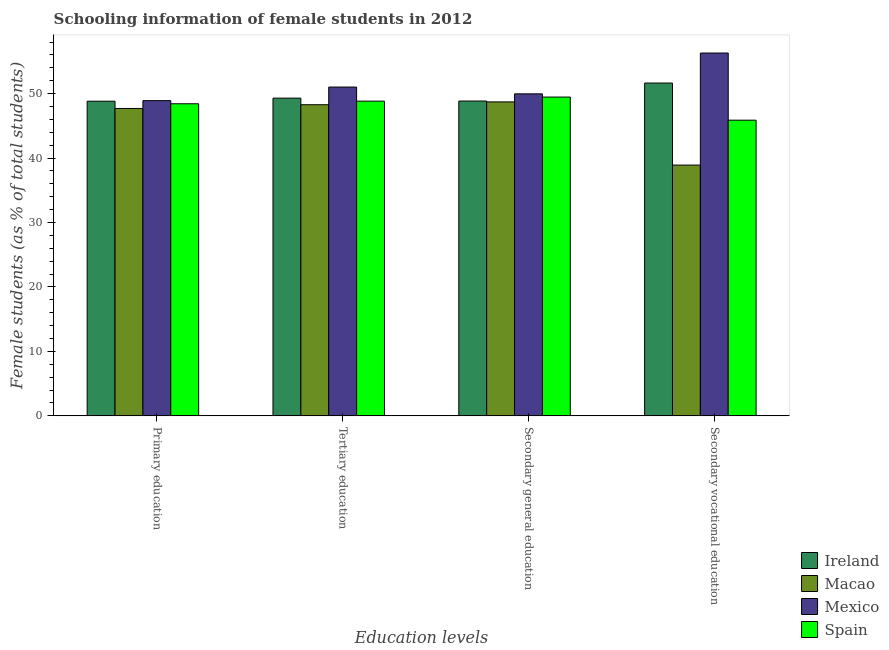How many different coloured bars are there?
Provide a succinct answer. 4. How many groups of bars are there?
Offer a very short reply. 4. Are the number of bars on each tick of the X-axis equal?
Offer a very short reply. Yes. How many bars are there on the 1st tick from the left?
Your response must be concise. 4. How many bars are there on the 2nd tick from the right?
Provide a short and direct response. 4. What is the label of the 3rd group of bars from the left?
Make the answer very short. Secondary general education. What is the percentage of female students in primary education in Macao?
Provide a short and direct response. 47.7. Across all countries, what is the maximum percentage of female students in tertiary education?
Offer a terse response. 51.02. Across all countries, what is the minimum percentage of female students in secondary vocational education?
Give a very brief answer. 38.91. In which country was the percentage of female students in secondary vocational education minimum?
Your response must be concise. Macao. What is the total percentage of female students in secondary education in the graph?
Your answer should be compact. 197. What is the difference between the percentage of female students in primary education in Ireland and that in Spain?
Make the answer very short. 0.4. What is the difference between the percentage of female students in primary education in Spain and the percentage of female students in secondary vocational education in Macao?
Offer a terse response. 9.51. What is the average percentage of female students in tertiary education per country?
Ensure brevity in your answer.  49.36. What is the difference between the percentage of female students in secondary education and percentage of female students in primary education in Ireland?
Your answer should be compact. 0.02. In how many countries, is the percentage of female students in secondary vocational education greater than 8 %?
Provide a short and direct response. 4. What is the ratio of the percentage of female students in primary education in Mexico to that in Spain?
Your answer should be compact. 1.01. What is the difference between the highest and the second highest percentage of female students in secondary vocational education?
Keep it short and to the point. 4.66. What is the difference between the highest and the lowest percentage of female students in secondary education?
Make the answer very short. 1.25. In how many countries, is the percentage of female students in tertiary education greater than the average percentage of female students in tertiary education taken over all countries?
Your answer should be compact. 1. Is the sum of the percentage of female students in primary education in Spain and Ireland greater than the maximum percentage of female students in secondary vocational education across all countries?
Your response must be concise. Yes. Is it the case that in every country, the sum of the percentage of female students in secondary vocational education and percentage of female students in tertiary education is greater than the sum of percentage of female students in primary education and percentage of female students in secondary education?
Make the answer very short. Yes. What does the 1st bar from the left in Primary education represents?
Your answer should be very brief. Ireland. What does the 2nd bar from the right in Primary education represents?
Keep it short and to the point. Mexico. Is it the case that in every country, the sum of the percentage of female students in primary education and percentage of female students in tertiary education is greater than the percentage of female students in secondary education?
Offer a terse response. Yes. How many countries are there in the graph?
Your response must be concise. 4. What is the difference between two consecutive major ticks on the Y-axis?
Make the answer very short. 10. Are the values on the major ticks of Y-axis written in scientific E-notation?
Your answer should be very brief. No. Does the graph contain grids?
Your response must be concise. No. Where does the legend appear in the graph?
Offer a very short reply. Bottom right. How many legend labels are there?
Make the answer very short. 4. What is the title of the graph?
Provide a succinct answer. Schooling information of female students in 2012. Does "Tunisia" appear as one of the legend labels in the graph?
Give a very brief answer. No. What is the label or title of the X-axis?
Offer a terse response. Education levels. What is the label or title of the Y-axis?
Make the answer very short. Female students (as % of total students). What is the Female students (as % of total students) of Ireland in Primary education?
Ensure brevity in your answer.  48.83. What is the Female students (as % of total students) in Macao in Primary education?
Offer a terse response. 47.7. What is the Female students (as % of total students) of Mexico in Primary education?
Give a very brief answer. 48.91. What is the Female students (as % of total students) in Spain in Primary education?
Offer a very short reply. 48.43. What is the Female students (as % of total students) in Ireland in Tertiary education?
Offer a terse response. 49.3. What is the Female students (as % of total students) of Macao in Tertiary education?
Your answer should be compact. 48.28. What is the Female students (as % of total students) of Mexico in Tertiary education?
Give a very brief answer. 51.02. What is the Female students (as % of total students) of Spain in Tertiary education?
Provide a short and direct response. 48.83. What is the Female students (as % of total students) of Ireland in Secondary general education?
Give a very brief answer. 48.85. What is the Female students (as % of total students) of Macao in Secondary general education?
Your answer should be very brief. 48.72. What is the Female students (as % of total students) in Mexico in Secondary general education?
Keep it short and to the point. 49.97. What is the Female students (as % of total students) in Spain in Secondary general education?
Make the answer very short. 49.47. What is the Female students (as % of total students) of Ireland in Secondary vocational education?
Provide a short and direct response. 51.64. What is the Female students (as % of total students) of Macao in Secondary vocational education?
Offer a very short reply. 38.91. What is the Female students (as % of total students) in Mexico in Secondary vocational education?
Keep it short and to the point. 56.3. What is the Female students (as % of total students) of Spain in Secondary vocational education?
Offer a very short reply. 45.88. Across all Education levels, what is the maximum Female students (as % of total students) of Ireland?
Keep it short and to the point. 51.64. Across all Education levels, what is the maximum Female students (as % of total students) in Macao?
Keep it short and to the point. 48.72. Across all Education levels, what is the maximum Female students (as % of total students) in Mexico?
Your answer should be very brief. 56.3. Across all Education levels, what is the maximum Female students (as % of total students) of Spain?
Ensure brevity in your answer.  49.47. Across all Education levels, what is the minimum Female students (as % of total students) of Ireland?
Provide a short and direct response. 48.83. Across all Education levels, what is the minimum Female students (as % of total students) of Macao?
Make the answer very short. 38.91. Across all Education levels, what is the minimum Female students (as % of total students) of Mexico?
Keep it short and to the point. 48.91. Across all Education levels, what is the minimum Female students (as % of total students) in Spain?
Keep it short and to the point. 45.88. What is the total Female students (as % of total students) of Ireland in the graph?
Your answer should be compact. 198.62. What is the total Female students (as % of total students) in Macao in the graph?
Offer a very short reply. 183.61. What is the total Female students (as % of total students) of Mexico in the graph?
Your answer should be compact. 206.2. What is the total Female students (as % of total students) of Spain in the graph?
Your answer should be compact. 192.61. What is the difference between the Female students (as % of total students) in Ireland in Primary education and that in Tertiary education?
Provide a succinct answer. -0.48. What is the difference between the Female students (as % of total students) in Macao in Primary education and that in Tertiary education?
Your answer should be compact. -0.58. What is the difference between the Female students (as % of total students) in Mexico in Primary education and that in Tertiary education?
Provide a succinct answer. -2.11. What is the difference between the Female students (as % of total students) of Spain in Primary education and that in Tertiary education?
Your answer should be compact. -0.41. What is the difference between the Female students (as % of total students) of Ireland in Primary education and that in Secondary general education?
Provide a succinct answer. -0.02. What is the difference between the Female students (as % of total students) of Macao in Primary education and that in Secondary general education?
Offer a very short reply. -1.02. What is the difference between the Female students (as % of total students) of Mexico in Primary education and that in Secondary general education?
Make the answer very short. -1.05. What is the difference between the Female students (as % of total students) of Spain in Primary education and that in Secondary general education?
Provide a short and direct response. -1.04. What is the difference between the Female students (as % of total students) of Ireland in Primary education and that in Secondary vocational education?
Your answer should be compact. -2.82. What is the difference between the Female students (as % of total students) in Macao in Primary education and that in Secondary vocational education?
Give a very brief answer. 8.79. What is the difference between the Female students (as % of total students) in Mexico in Primary education and that in Secondary vocational education?
Your answer should be compact. -7.39. What is the difference between the Female students (as % of total students) in Spain in Primary education and that in Secondary vocational education?
Provide a short and direct response. 2.55. What is the difference between the Female students (as % of total students) in Ireland in Tertiary education and that in Secondary general education?
Your answer should be compact. 0.45. What is the difference between the Female students (as % of total students) of Macao in Tertiary education and that in Secondary general education?
Offer a terse response. -0.44. What is the difference between the Female students (as % of total students) in Mexico in Tertiary education and that in Secondary general education?
Give a very brief answer. 1.05. What is the difference between the Female students (as % of total students) of Spain in Tertiary education and that in Secondary general education?
Your answer should be very brief. -0.63. What is the difference between the Female students (as % of total students) of Ireland in Tertiary education and that in Secondary vocational education?
Your response must be concise. -2.34. What is the difference between the Female students (as % of total students) of Macao in Tertiary education and that in Secondary vocational education?
Your answer should be very brief. 9.37. What is the difference between the Female students (as % of total students) of Mexico in Tertiary education and that in Secondary vocational education?
Offer a terse response. -5.28. What is the difference between the Female students (as % of total students) of Spain in Tertiary education and that in Secondary vocational education?
Keep it short and to the point. 2.95. What is the difference between the Female students (as % of total students) in Ireland in Secondary general education and that in Secondary vocational education?
Keep it short and to the point. -2.79. What is the difference between the Female students (as % of total students) of Macao in Secondary general education and that in Secondary vocational education?
Offer a very short reply. 9.8. What is the difference between the Female students (as % of total students) in Mexico in Secondary general education and that in Secondary vocational education?
Offer a terse response. -6.33. What is the difference between the Female students (as % of total students) in Spain in Secondary general education and that in Secondary vocational education?
Offer a very short reply. 3.59. What is the difference between the Female students (as % of total students) of Ireland in Primary education and the Female students (as % of total students) of Macao in Tertiary education?
Keep it short and to the point. 0.55. What is the difference between the Female students (as % of total students) in Ireland in Primary education and the Female students (as % of total students) in Mexico in Tertiary education?
Your answer should be very brief. -2.19. What is the difference between the Female students (as % of total students) in Ireland in Primary education and the Female students (as % of total students) in Spain in Tertiary education?
Give a very brief answer. -0.01. What is the difference between the Female students (as % of total students) in Macao in Primary education and the Female students (as % of total students) in Mexico in Tertiary education?
Offer a very short reply. -3.32. What is the difference between the Female students (as % of total students) in Macao in Primary education and the Female students (as % of total students) in Spain in Tertiary education?
Provide a succinct answer. -1.13. What is the difference between the Female students (as % of total students) of Mexico in Primary education and the Female students (as % of total students) of Spain in Tertiary education?
Provide a short and direct response. 0.08. What is the difference between the Female students (as % of total students) of Ireland in Primary education and the Female students (as % of total students) of Macao in Secondary general education?
Make the answer very short. 0.11. What is the difference between the Female students (as % of total students) of Ireland in Primary education and the Female students (as % of total students) of Mexico in Secondary general education?
Your answer should be compact. -1.14. What is the difference between the Female students (as % of total students) of Ireland in Primary education and the Female students (as % of total students) of Spain in Secondary general education?
Provide a short and direct response. -0.64. What is the difference between the Female students (as % of total students) in Macao in Primary education and the Female students (as % of total students) in Mexico in Secondary general education?
Make the answer very short. -2.27. What is the difference between the Female students (as % of total students) in Macao in Primary education and the Female students (as % of total students) in Spain in Secondary general education?
Offer a very short reply. -1.77. What is the difference between the Female students (as % of total students) in Mexico in Primary education and the Female students (as % of total students) in Spain in Secondary general education?
Make the answer very short. -0.55. What is the difference between the Female students (as % of total students) of Ireland in Primary education and the Female students (as % of total students) of Macao in Secondary vocational education?
Your answer should be compact. 9.91. What is the difference between the Female students (as % of total students) in Ireland in Primary education and the Female students (as % of total students) in Mexico in Secondary vocational education?
Offer a terse response. -7.48. What is the difference between the Female students (as % of total students) in Ireland in Primary education and the Female students (as % of total students) in Spain in Secondary vocational education?
Offer a terse response. 2.95. What is the difference between the Female students (as % of total students) in Macao in Primary education and the Female students (as % of total students) in Mexico in Secondary vocational education?
Offer a terse response. -8.6. What is the difference between the Female students (as % of total students) in Macao in Primary education and the Female students (as % of total students) in Spain in Secondary vocational education?
Make the answer very short. 1.82. What is the difference between the Female students (as % of total students) in Mexico in Primary education and the Female students (as % of total students) in Spain in Secondary vocational education?
Ensure brevity in your answer.  3.03. What is the difference between the Female students (as % of total students) of Ireland in Tertiary education and the Female students (as % of total students) of Macao in Secondary general education?
Offer a terse response. 0.58. What is the difference between the Female students (as % of total students) of Ireland in Tertiary education and the Female students (as % of total students) of Mexico in Secondary general education?
Keep it short and to the point. -0.67. What is the difference between the Female students (as % of total students) of Ireland in Tertiary education and the Female students (as % of total students) of Spain in Secondary general education?
Offer a terse response. -0.17. What is the difference between the Female students (as % of total students) of Macao in Tertiary education and the Female students (as % of total students) of Mexico in Secondary general education?
Offer a terse response. -1.69. What is the difference between the Female students (as % of total students) of Macao in Tertiary education and the Female students (as % of total students) of Spain in Secondary general education?
Provide a short and direct response. -1.19. What is the difference between the Female students (as % of total students) of Mexico in Tertiary education and the Female students (as % of total students) of Spain in Secondary general education?
Offer a very short reply. 1.55. What is the difference between the Female students (as % of total students) in Ireland in Tertiary education and the Female students (as % of total students) in Macao in Secondary vocational education?
Your answer should be compact. 10.39. What is the difference between the Female students (as % of total students) in Ireland in Tertiary education and the Female students (as % of total students) in Mexico in Secondary vocational education?
Ensure brevity in your answer.  -7. What is the difference between the Female students (as % of total students) of Ireland in Tertiary education and the Female students (as % of total students) of Spain in Secondary vocational education?
Provide a short and direct response. 3.42. What is the difference between the Female students (as % of total students) in Macao in Tertiary education and the Female students (as % of total students) in Mexico in Secondary vocational education?
Keep it short and to the point. -8.02. What is the difference between the Female students (as % of total students) of Macao in Tertiary education and the Female students (as % of total students) of Spain in Secondary vocational education?
Offer a very short reply. 2.4. What is the difference between the Female students (as % of total students) in Mexico in Tertiary education and the Female students (as % of total students) in Spain in Secondary vocational education?
Provide a short and direct response. 5.14. What is the difference between the Female students (as % of total students) in Ireland in Secondary general education and the Female students (as % of total students) in Macao in Secondary vocational education?
Your answer should be very brief. 9.94. What is the difference between the Female students (as % of total students) in Ireland in Secondary general education and the Female students (as % of total students) in Mexico in Secondary vocational education?
Provide a short and direct response. -7.45. What is the difference between the Female students (as % of total students) of Ireland in Secondary general education and the Female students (as % of total students) of Spain in Secondary vocational education?
Your response must be concise. 2.97. What is the difference between the Female students (as % of total students) of Macao in Secondary general education and the Female students (as % of total students) of Mexico in Secondary vocational education?
Your answer should be very brief. -7.58. What is the difference between the Female students (as % of total students) of Macao in Secondary general education and the Female students (as % of total students) of Spain in Secondary vocational education?
Give a very brief answer. 2.84. What is the difference between the Female students (as % of total students) of Mexico in Secondary general education and the Female students (as % of total students) of Spain in Secondary vocational education?
Your response must be concise. 4.09. What is the average Female students (as % of total students) in Ireland per Education levels?
Offer a terse response. 49.65. What is the average Female students (as % of total students) in Macao per Education levels?
Offer a very short reply. 45.9. What is the average Female students (as % of total students) of Mexico per Education levels?
Keep it short and to the point. 51.55. What is the average Female students (as % of total students) in Spain per Education levels?
Offer a very short reply. 48.15. What is the difference between the Female students (as % of total students) of Ireland and Female students (as % of total students) of Macao in Primary education?
Your response must be concise. 1.13. What is the difference between the Female students (as % of total students) in Ireland and Female students (as % of total students) in Mexico in Primary education?
Your answer should be very brief. -0.09. What is the difference between the Female students (as % of total students) in Ireland and Female students (as % of total students) in Spain in Primary education?
Keep it short and to the point. 0.4. What is the difference between the Female students (as % of total students) in Macao and Female students (as % of total students) in Mexico in Primary education?
Your answer should be compact. -1.21. What is the difference between the Female students (as % of total students) in Macao and Female students (as % of total students) in Spain in Primary education?
Ensure brevity in your answer.  -0.73. What is the difference between the Female students (as % of total students) of Mexico and Female students (as % of total students) of Spain in Primary education?
Give a very brief answer. 0.49. What is the difference between the Female students (as % of total students) of Ireland and Female students (as % of total students) of Mexico in Tertiary education?
Give a very brief answer. -1.72. What is the difference between the Female students (as % of total students) in Ireland and Female students (as % of total students) in Spain in Tertiary education?
Your answer should be compact. 0.47. What is the difference between the Female students (as % of total students) of Macao and Female students (as % of total students) of Mexico in Tertiary education?
Your answer should be very brief. -2.74. What is the difference between the Female students (as % of total students) in Macao and Female students (as % of total students) in Spain in Tertiary education?
Offer a very short reply. -0.55. What is the difference between the Female students (as % of total students) of Mexico and Female students (as % of total students) of Spain in Tertiary education?
Provide a short and direct response. 2.19. What is the difference between the Female students (as % of total students) in Ireland and Female students (as % of total students) in Macao in Secondary general education?
Provide a short and direct response. 0.13. What is the difference between the Female students (as % of total students) in Ireland and Female students (as % of total students) in Mexico in Secondary general education?
Offer a terse response. -1.12. What is the difference between the Female students (as % of total students) in Ireland and Female students (as % of total students) in Spain in Secondary general education?
Provide a succinct answer. -0.62. What is the difference between the Female students (as % of total students) of Macao and Female students (as % of total students) of Mexico in Secondary general education?
Keep it short and to the point. -1.25. What is the difference between the Female students (as % of total students) of Macao and Female students (as % of total students) of Spain in Secondary general education?
Provide a succinct answer. -0.75. What is the difference between the Female students (as % of total students) of Mexico and Female students (as % of total students) of Spain in Secondary general education?
Offer a very short reply. 0.5. What is the difference between the Female students (as % of total students) in Ireland and Female students (as % of total students) in Macao in Secondary vocational education?
Your answer should be very brief. 12.73. What is the difference between the Female students (as % of total students) in Ireland and Female students (as % of total students) in Mexico in Secondary vocational education?
Keep it short and to the point. -4.66. What is the difference between the Female students (as % of total students) of Ireland and Female students (as % of total students) of Spain in Secondary vocational education?
Provide a short and direct response. 5.76. What is the difference between the Female students (as % of total students) of Macao and Female students (as % of total students) of Mexico in Secondary vocational education?
Provide a succinct answer. -17.39. What is the difference between the Female students (as % of total students) in Macao and Female students (as % of total students) in Spain in Secondary vocational education?
Ensure brevity in your answer.  -6.97. What is the difference between the Female students (as % of total students) of Mexico and Female students (as % of total students) of Spain in Secondary vocational education?
Keep it short and to the point. 10.42. What is the ratio of the Female students (as % of total students) in Mexico in Primary education to that in Tertiary education?
Provide a short and direct response. 0.96. What is the ratio of the Female students (as % of total students) in Spain in Primary education to that in Tertiary education?
Provide a succinct answer. 0.99. What is the ratio of the Female students (as % of total students) in Macao in Primary education to that in Secondary general education?
Offer a terse response. 0.98. What is the ratio of the Female students (as % of total students) of Mexico in Primary education to that in Secondary general education?
Your response must be concise. 0.98. What is the ratio of the Female students (as % of total students) in Ireland in Primary education to that in Secondary vocational education?
Ensure brevity in your answer.  0.95. What is the ratio of the Female students (as % of total students) of Macao in Primary education to that in Secondary vocational education?
Provide a short and direct response. 1.23. What is the ratio of the Female students (as % of total students) of Mexico in Primary education to that in Secondary vocational education?
Offer a terse response. 0.87. What is the ratio of the Female students (as % of total students) in Spain in Primary education to that in Secondary vocational education?
Ensure brevity in your answer.  1.06. What is the ratio of the Female students (as % of total students) of Ireland in Tertiary education to that in Secondary general education?
Keep it short and to the point. 1.01. What is the ratio of the Female students (as % of total students) in Macao in Tertiary education to that in Secondary general education?
Offer a terse response. 0.99. What is the ratio of the Female students (as % of total students) in Mexico in Tertiary education to that in Secondary general education?
Your response must be concise. 1.02. What is the ratio of the Female students (as % of total students) in Spain in Tertiary education to that in Secondary general education?
Ensure brevity in your answer.  0.99. What is the ratio of the Female students (as % of total students) in Ireland in Tertiary education to that in Secondary vocational education?
Provide a succinct answer. 0.95. What is the ratio of the Female students (as % of total students) of Macao in Tertiary education to that in Secondary vocational education?
Ensure brevity in your answer.  1.24. What is the ratio of the Female students (as % of total students) in Mexico in Tertiary education to that in Secondary vocational education?
Offer a terse response. 0.91. What is the ratio of the Female students (as % of total students) of Spain in Tertiary education to that in Secondary vocational education?
Make the answer very short. 1.06. What is the ratio of the Female students (as % of total students) in Ireland in Secondary general education to that in Secondary vocational education?
Your answer should be compact. 0.95. What is the ratio of the Female students (as % of total students) of Macao in Secondary general education to that in Secondary vocational education?
Your answer should be very brief. 1.25. What is the ratio of the Female students (as % of total students) of Mexico in Secondary general education to that in Secondary vocational education?
Offer a very short reply. 0.89. What is the ratio of the Female students (as % of total students) in Spain in Secondary general education to that in Secondary vocational education?
Offer a terse response. 1.08. What is the difference between the highest and the second highest Female students (as % of total students) of Ireland?
Provide a short and direct response. 2.34. What is the difference between the highest and the second highest Female students (as % of total students) of Macao?
Your response must be concise. 0.44. What is the difference between the highest and the second highest Female students (as % of total students) in Mexico?
Make the answer very short. 5.28. What is the difference between the highest and the second highest Female students (as % of total students) in Spain?
Offer a terse response. 0.63. What is the difference between the highest and the lowest Female students (as % of total students) of Ireland?
Provide a short and direct response. 2.82. What is the difference between the highest and the lowest Female students (as % of total students) of Macao?
Your response must be concise. 9.8. What is the difference between the highest and the lowest Female students (as % of total students) of Mexico?
Your response must be concise. 7.39. What is the difference between the highest and the lowest Female students (as % of total students) of Spain?
Your answer should be very brief. 3.59. 